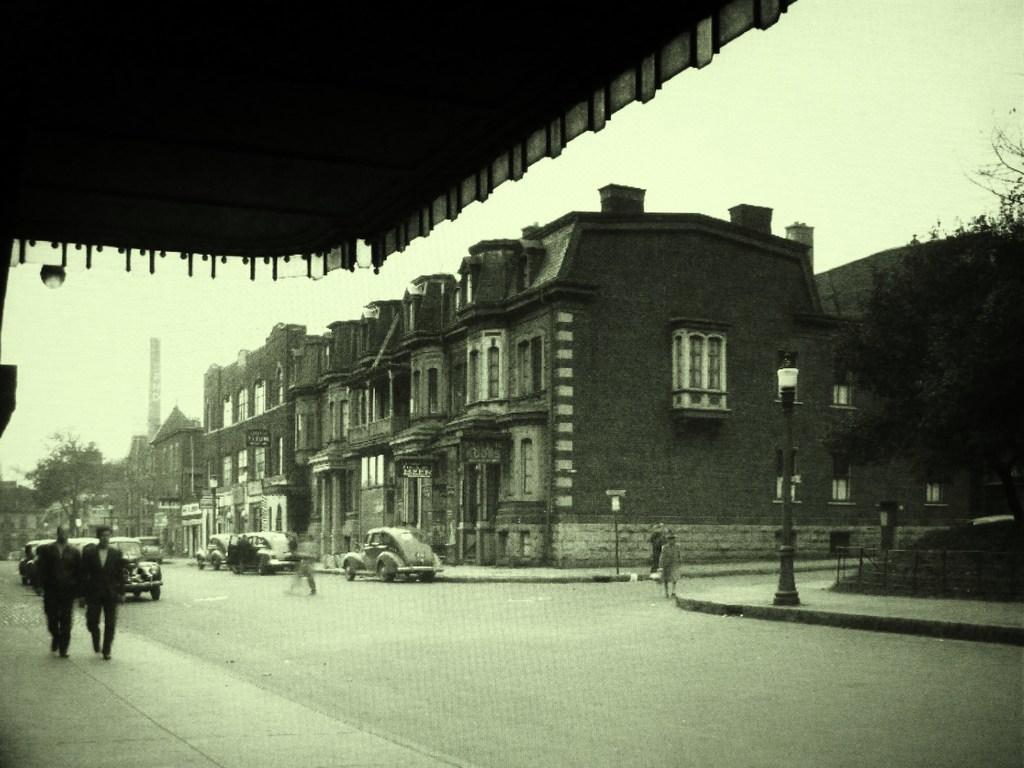Describe this image in one or two sentences. In this picture I can see buildings, trees and I can see few cars on the road and I can see few people walking and few pole lights and I can see sky. 